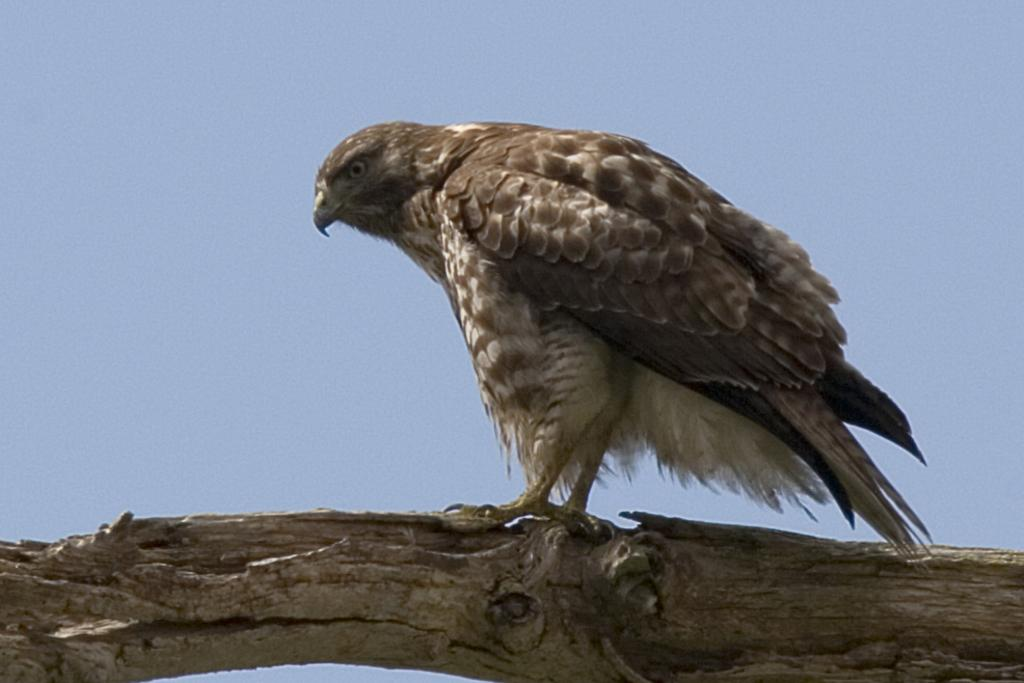What type of animal can be seen in the image? There is a bird in the image. Where is the bird located? The bird is on a wooden bark. What type of glass is the bird using to read an expert's brain in the image? There is no glass, expert, or brain present in the image; it only features a bird on a wooden bark. 